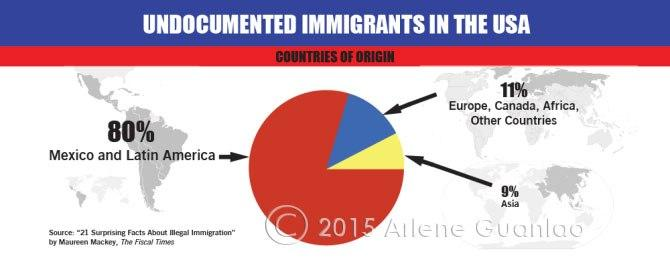Point out several critical features in this image. The majority of undocumented immigrants in the USA come from Mexico and Latin America. According to recent statistics, undocumented immigrants in the USA comprise of 9% of the total population, with the majority of them coming from Asia. 